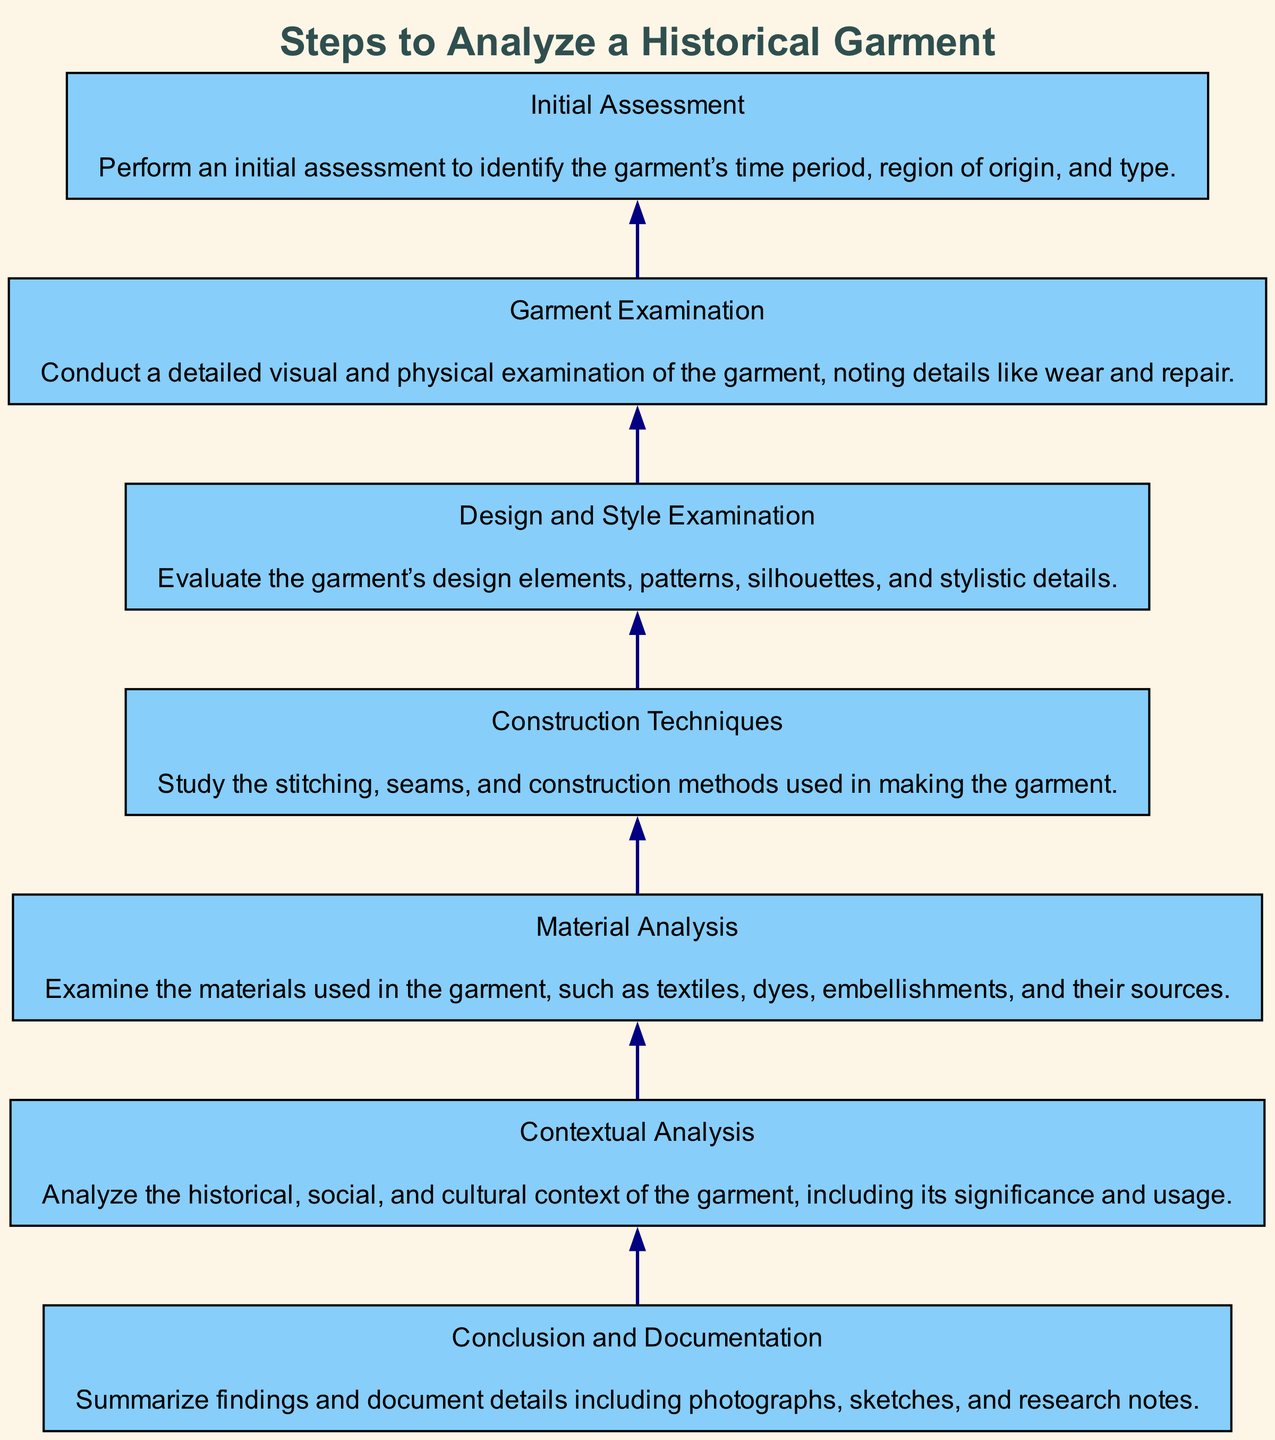What is the first step in the flow chart? The flow chart progresses from bottom to top, making the last node listed the first step in the analysis process. Referring to the diagram, the last element at the bottom is "Initial Assessment," indicating that this is the first action taken when analyzing a historical garment.
Answer: Initial Assessment How many nodes are there in the diagram? By counting the individual steps listed in the diagram, we see there are seven distinct elements or nodes in the flow chart, which outline the analytical process.
Answer: 7 What follows 'Garment Examination' in the flow? Looking at the flow of the diagram from the bottom to the top, 'Garment Examination' is directly followed by 'Design and Style Examination,' which signifies the next step in the process of analyzing a historical garment.
Answer: Design and Style Examination Which step comes before 'Conclusion and Documentation'? Tracing the connections in the flow chart upwards, we observe that 'Contextual Analysis' is the step that directly precedes 'Conclusion and Documentation,' indicating the final analysis before summarizing findings.
Answer: Contextual Analysis Name two types of analysis included in the steps. By reviewing the nodes in the diagram, we note various analysis types, specifically 'Material Analysis' and 'Contextual Analysis.' These both contribute scientific and social insights into the garment being studied.
Answer: Material Analysis, Contextual Analysis What is the significance of 'Construction Techniques' in the flow? Positioned before 'Design and Style Examination,' 'Construction Techniques' serves as a critical step where the methodology and skills used in making the garment are evaluated, which informs the stylistic analysis that follows.
Answer: Inform the stylistic analysis How does 'Material Analysis' relate to 'Garment Examination'? The flow chart indicates that 'Garment Examination' is directly after 'Material Analysis.' This means that analyzing the materials used in the garment is essential before conducting a detailed examination of the garment's physical characteristics.
Answer: Material analysis is essential before garment examination Which analysis step deals with the garment's cultural significance? In tracing through the diagram, it's clear that 'Contextual Analysis' is dedicated to examining the cultural and social importance of the garment within its time period, highlighting its historical relevance.
Answer: Contextual Analysis 